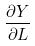<formula> <loc_0><loc_0><loc_500><loc_500>\frac { \partial Y } { \partial L }</formula> 